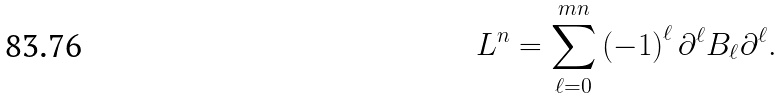Convert formula to latex. <formula><loc_0><loc_0><loc_500><loc_500>L ^ { n } = \sum _ { \ell = 0 } ^ { m n } \left ( - 1 \right ) ^ { \ell } \partial ^ { \ell } B _ { \ell } \partial ^ { \ell } .</formula> 